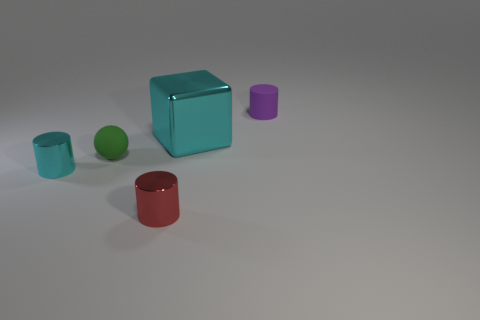Subtract all metallic cylinders. How many cylinders are left? 1 Add 1 tiny red shiny objects. How many objects exist? 6 Subtract all cubes. How many objects are left? 4 Add 4 purple objects. How many purple objects exist? 5 Subtract 1 cyan cylinders. How many objects are left? 4 Subtract all small balls. Subtract all cyan rubber things. How many objects are left? 4 Add 4 tiny green rubber spheres. How many tiny green rubber spheres are left? 5 